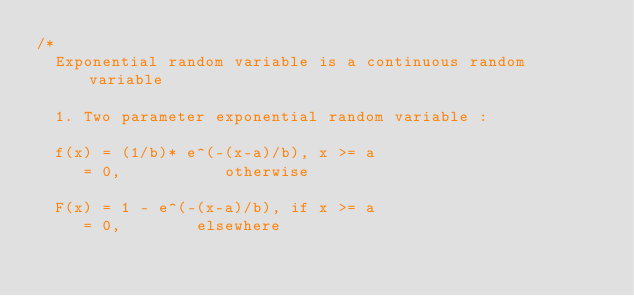<code> <loc_0><loc_0><loc_500><loc_500><_C++_>/*
	Exponential random variable is a continuous random variable

	1. Two parameter exponential random variable :
	
	f(x) = (1/b)* e^(-(x-a)/b), x >= a
		 = 0, 					otherwise

	F(x) = 1 - e^(-(x-a)/b), if x >= a
		 = 0,				 elsewhere
 
	</code> 